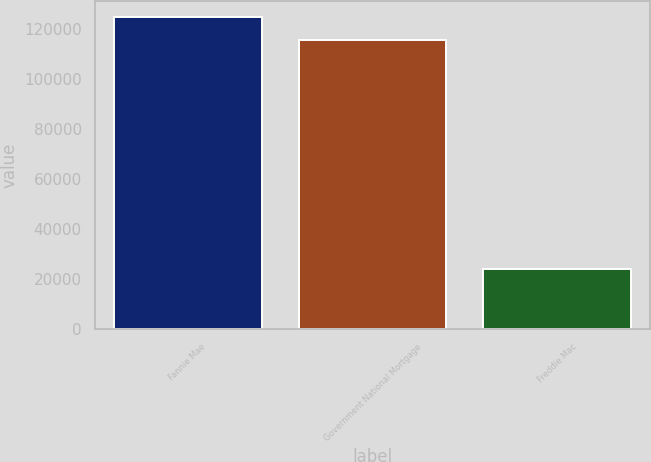Convert chart to OTSL. <chart><loc_0><loc_0><loc_500><loc_500><bar_chart><fcel>Fannie Mae<fcel>Government National Mortgage<fcel>Freddie Mac<nl><fcel>124777<fcel>115314<fcel>24075<nl></chart> 